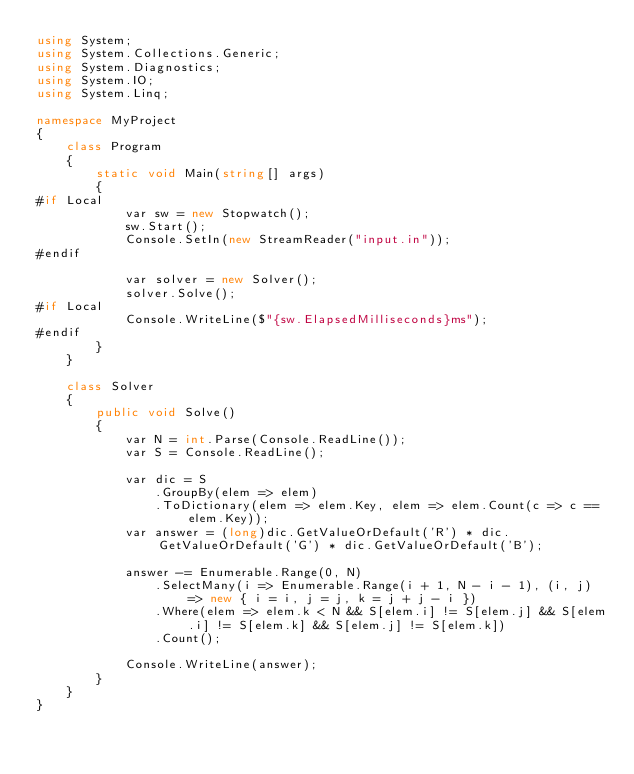<code> <loc_0><loc_0><loc_500><loc_500><_C#_>using System;
using System.Collections.Generic;
using System.Diagnostics;
using System.IO;
using System.Linq;

namespace MyProject
{
    class Program
    {
        static void Main(string[] args)
        {
#if Local
            var sw = new Stopwatch();
            sw.Start();
            Console.SetIn(new StreamReader("input.in"));
#endif

            var solver = new Solver();
            solver.Solve();
#if Local
            Console.WriteLine($"{sw.ElapsedMilliseconds}ms");
#endif
        }
    }

    class Solver
    {
        public void Solve()
        {
            var N = int.Parse(Console.ReadLine());
            var S = Console.ReadLine();

            var dic = S
                .GroupBy(elem => elem)
                .ToDictionary(elem => elem.Key, elem => elem.Count(c => c == elem.Key));
            var answer = (long)dic.GetValueOrDefault('R') * dic.GetValueOrDefault('G') * dic.GetValueOrDefault('B');

            answer -= Enumerable.Range(0, N)
                .SelectMany(i => Enumerable.Range(i + 1, N - i - 1), (i, j) => new { i = i, j = j, k = j + j - i })
                .Where(elem => elem.k < N && S[elem.i] != S[elem.j] && S[elem.i] != S[elem.k] && S[elem.j] != S[elem.k])
                .Count();

            Console.WriteLine(answer);
        }
    }
}
</code> 